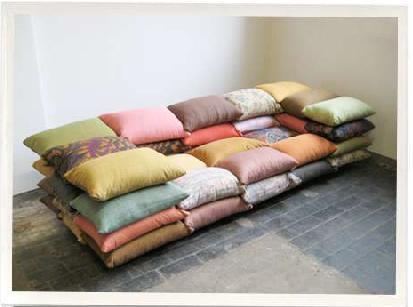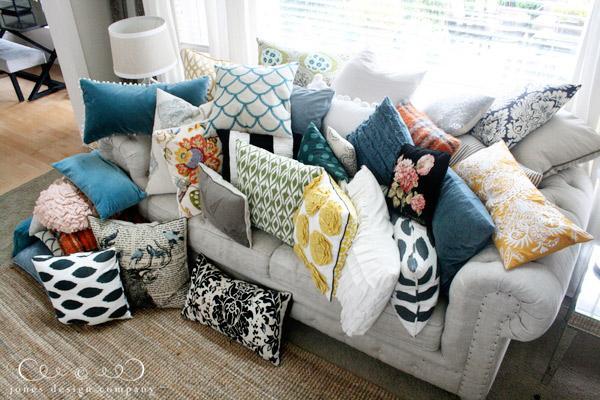The first image is the image on the left, the second image is the image on the right. Considering the images on both sides, is "In one image, pillows are stacked five across to form a couch-like seating area." valid? Answer yes or no. Yes. 